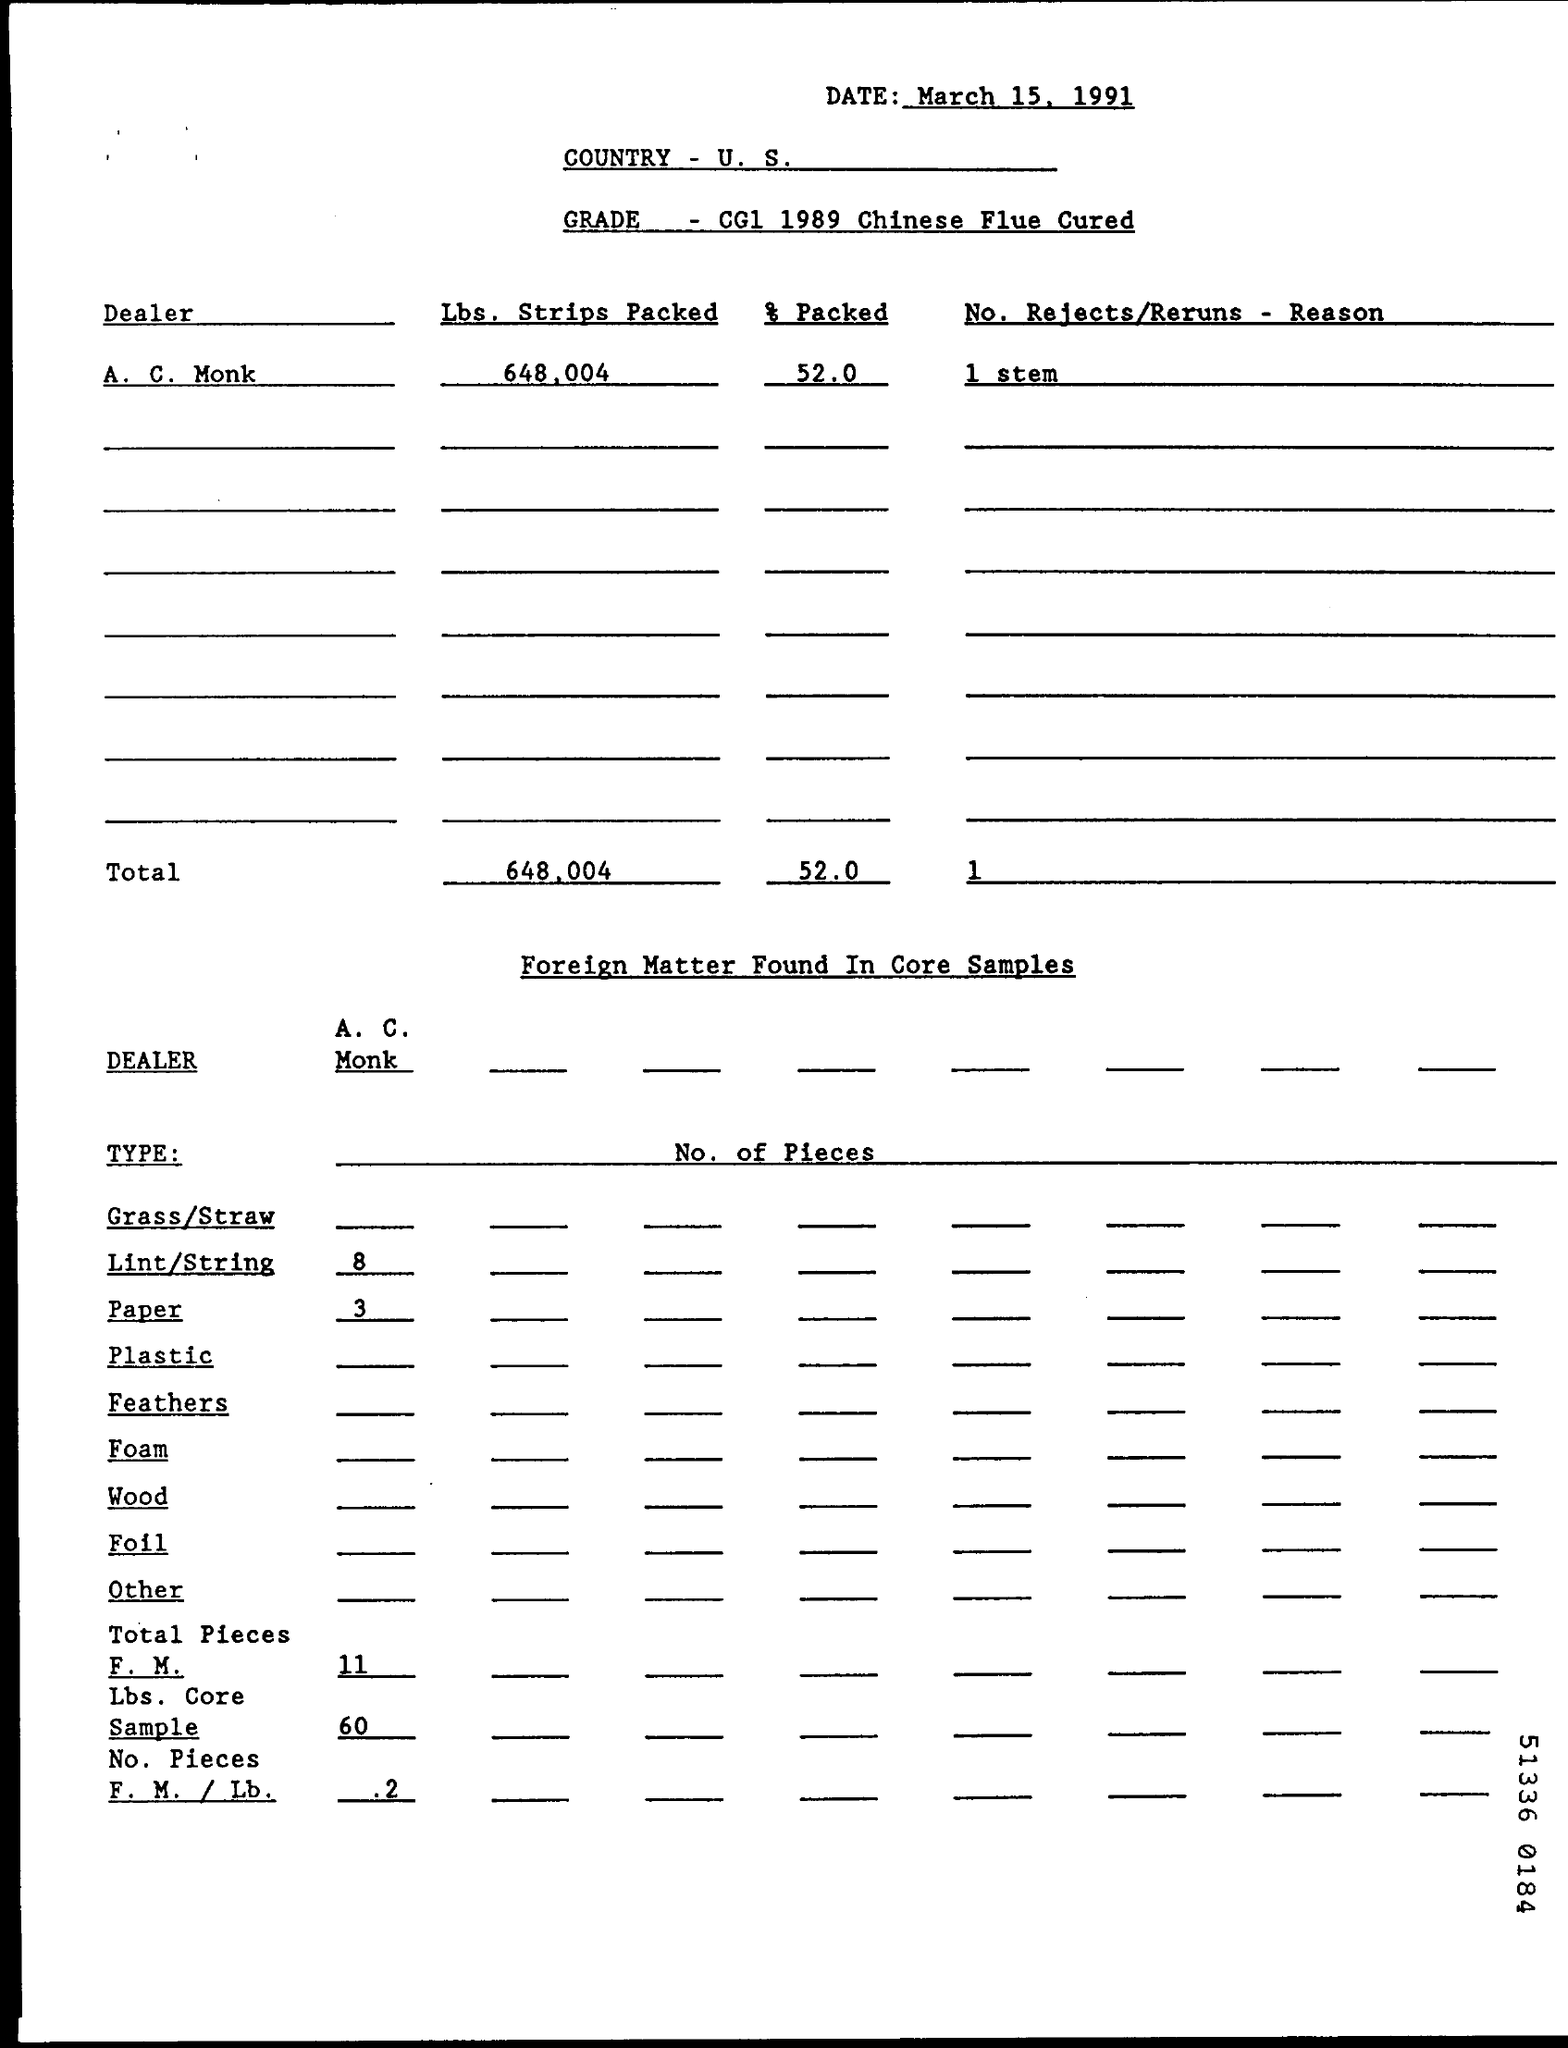When is the document dated?
Provide a succinct answer. March 15, 1991. What is the grade specified?
Ensure brevity in your answer.  CG1 1989 Chinese Flue Cured. What percentage was packed by A. C. Monk?
Offer a very short reply. 52.0. How many pieces of lint/string were found?
Keep it short and to the point. 8. 